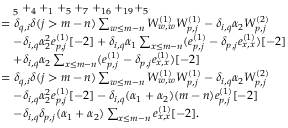Convert formula to latex. <formula><loc_0><loc_0><loc_500><loc_500>\begin{array} { r l } & { \quad _ { 5 } + _ { 4 } + _ { 1 } + _ { 5 } + _ { 7 } + _ { 1 6 } + _ { 1 9 } + _ { 5 } } \\ & { = \delta _ { q , i } \delta ( j > m - n ) \sum _ { \substack { w \leq m - n } } W _ { w , w } ^ { ( 1 ) } W _ { p , j } ^ { ( 1 ) } - \delta _ { i , q } \alpha _ { 2 } W _ { p , j } ^ { ( 2 ) } } \\ & { \quad - \delta _ { i , q } \alpha _ { 2 } ^ { 2 } e _ { p , j } ^ { ( 1 ) } [ - 2 ] + \delta _ { i , q } \alpha _ { 1 } \sum _ { x \leq m - n } ( e _ { p , j } ^ { ( 1 ) } - \delta _ { p , j } e _ { x , x } ^ { ( 1 ) } ) [ - 2 ] } \\ & { \quad + \delta _ { i , q } \alpha _ { 2 } \sum _ { x \leq m - n } ( e _ { p , j } ^ { ( 1 ) } - \delta _ { p , j } e _ { x , x } ^ { ( 1 ) } ) [ - 2 ] } \\ & { = \delta _ { q , i } \delta ( j > m - n ) \sum _ { \substack { w \leq m - n } } W _ { w , w } ^ { ( 1 ) } W _ { p , j } ^ { ( 1 ) } - \delta _ { i , q } \alpha _ { 2 } W _ { p , j } ^ { ( 2 ) } } \\ & { \quad - \delta _ { i , q } \alpha _ { 2 } ^ { 2 } e _ { p , j } ^ { ( 1 ) } [ - 2 ] - \delta _ { i , q } ( \alpha _ { 1 } + \alpha _ { 2 } ) ( m - n ) e _ { p , j } ^ { ( 1 ) } [ - 2 ] } \\ & { \quad - \delta _ { i , q } \delta _ { p , j } ( \alpha _ { 1 } + \alpha _ { 2 } ) \sum _ { x \leq m - n } e _ { x , x } ^ { ( 1 ) } [ - 2 ] . } \end{array}</formula> 